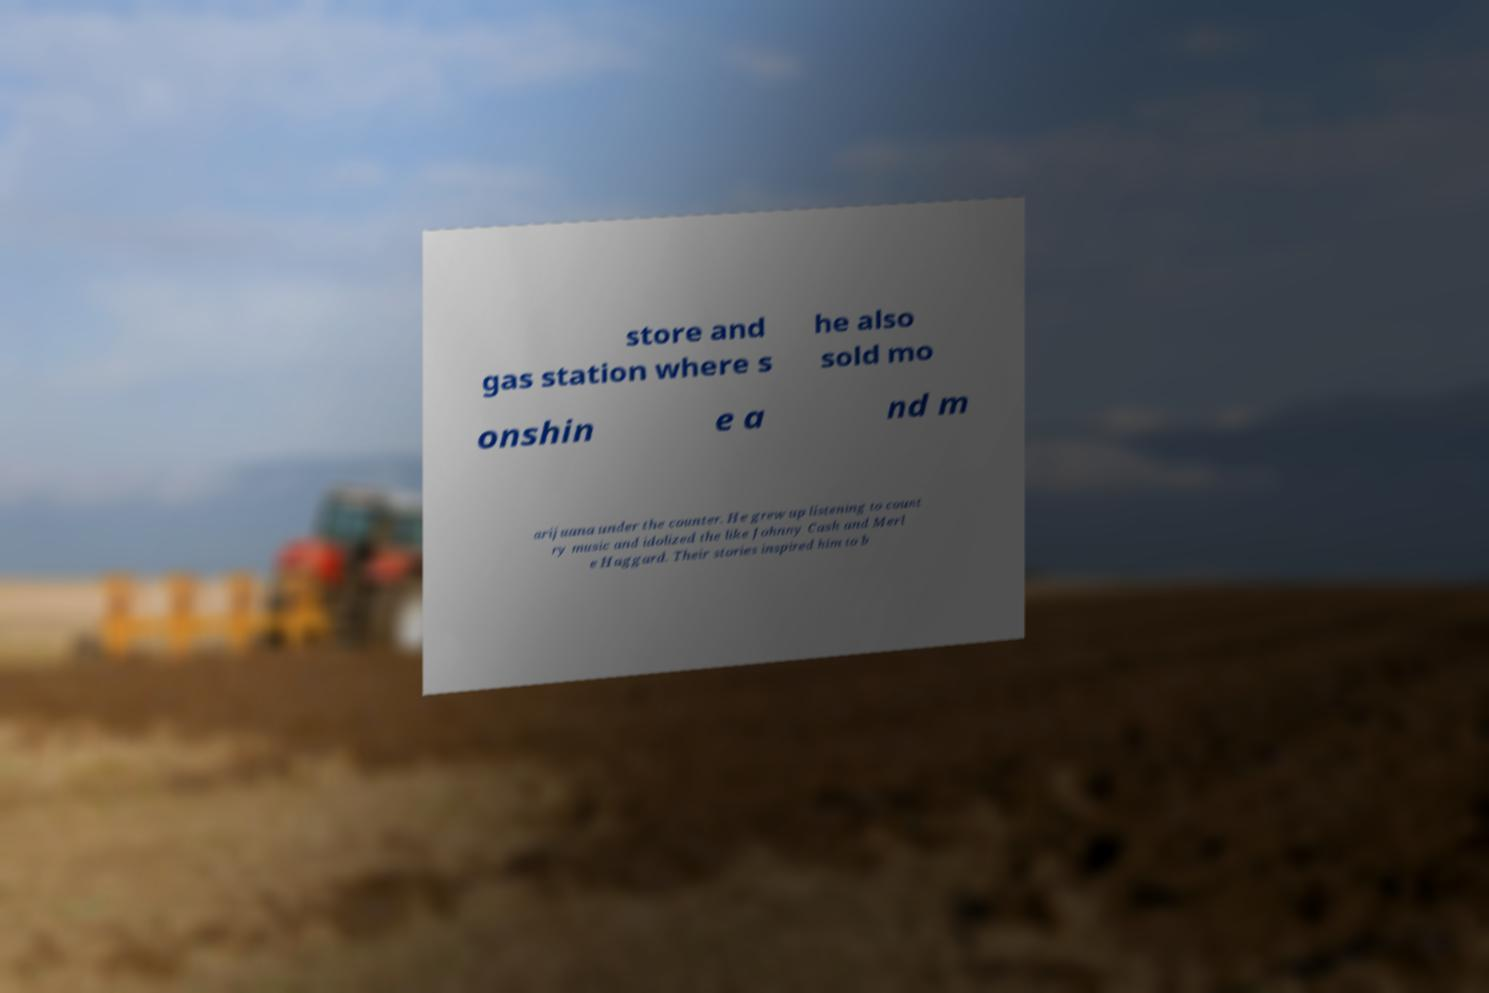There's text embedded in this image that I need extracted. Can you transcribe it verbatim? store and gas station where s he also sold mo onshin e a nd m arijuana under the counter. He grew up listening to count ry music and idolized the like Johnny Cash and Merl e Haggard. Their stories inspired him to b 